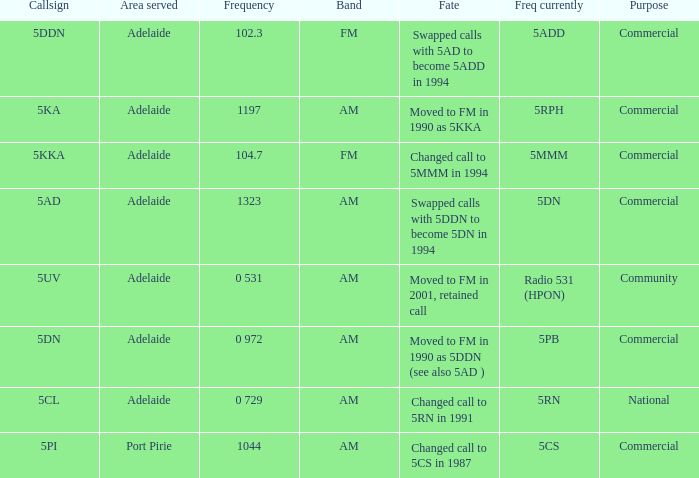What is the current freq for Frequency of 104.7? 5MMM. 